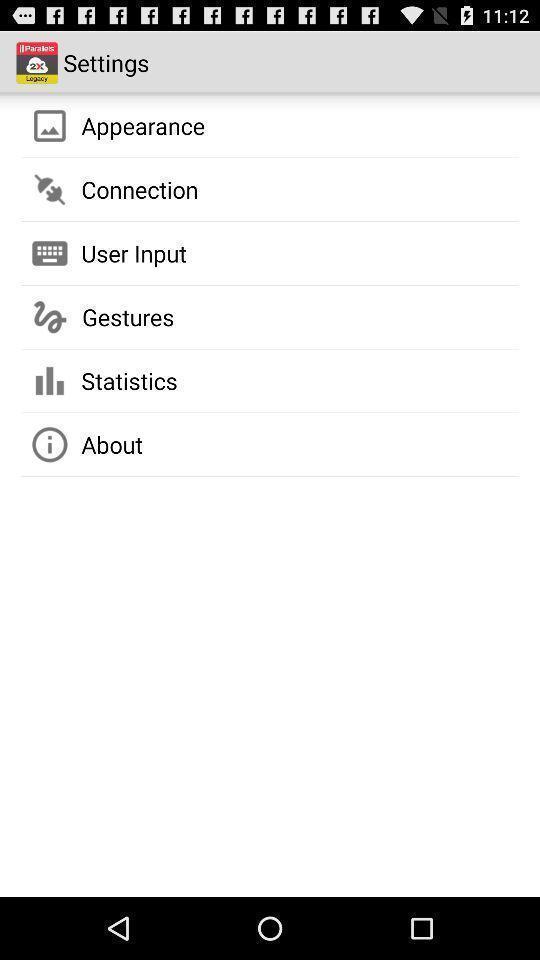What can you discern from this picture? Settings page with various options. 